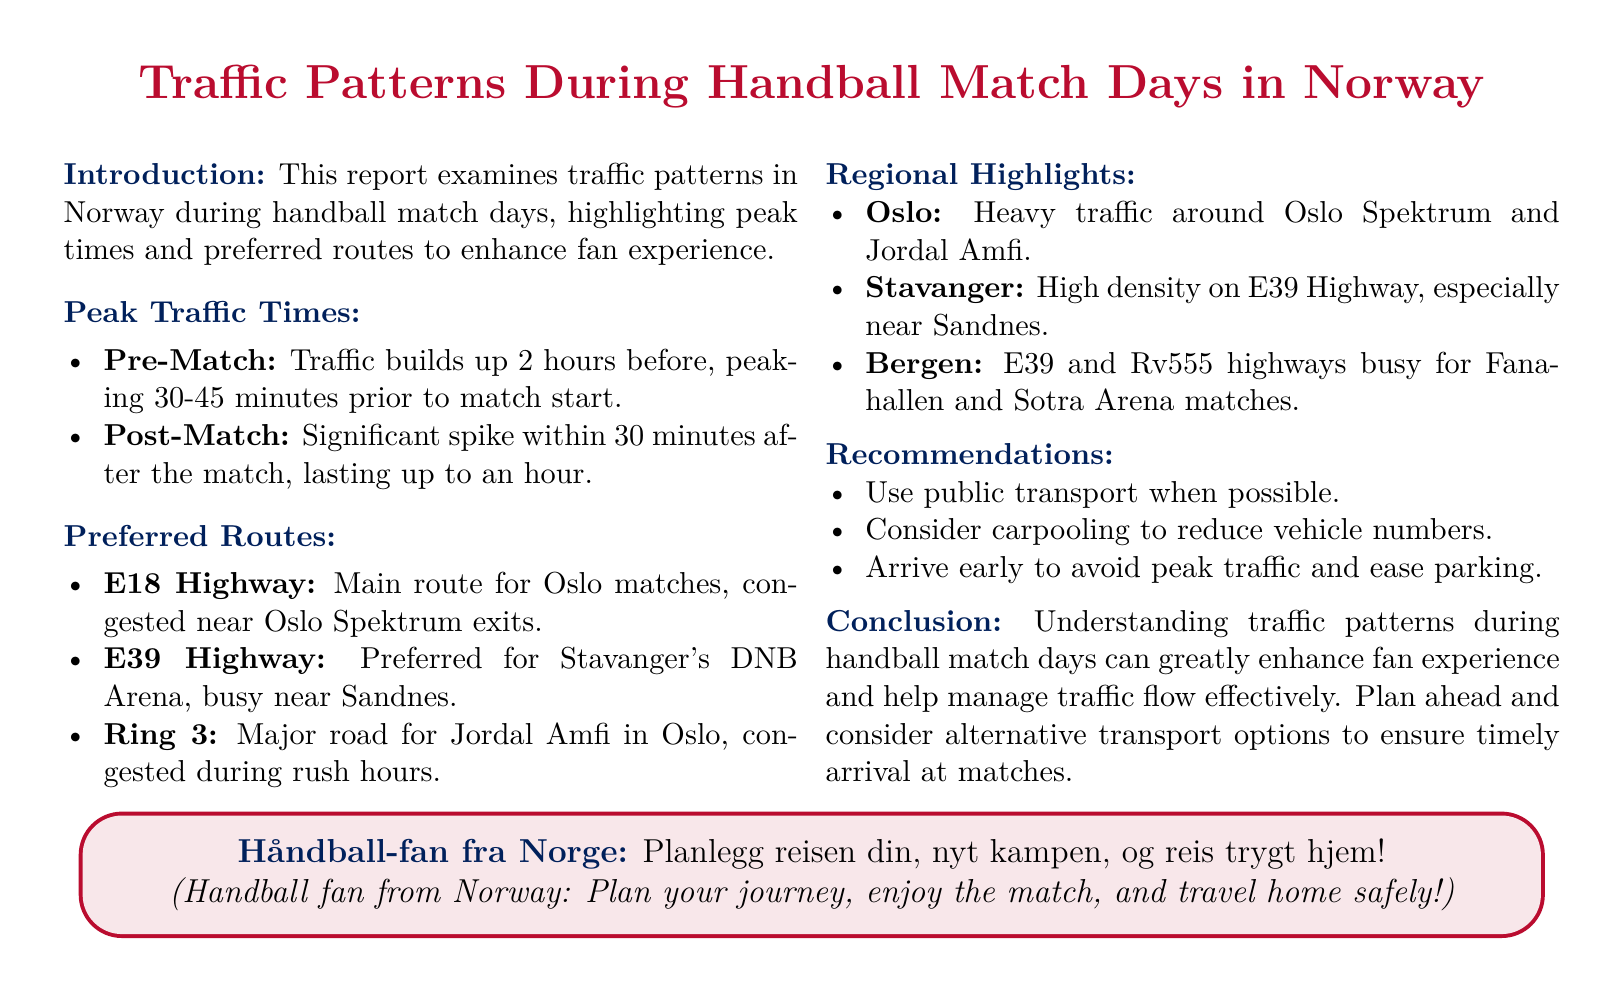What peaks in traffic occur 30-45 minutes before a match? The document states that traffic builds up 2 hours before, peaking 30-45 minutes prior to match start.
Answer: Pre-Match What is the primary route for Oslo matches? The report specifies that the E18 Highway is the main route for Oslo matches.
Answer: E18 Highway What are the peak traffic times after a match? The document mentions a significant spike within 30 minutes after the match, lasting up to an hour.
Answer: 30 minutes Which highway is busiest near Sandnes? The report indicates that the E39 Highway is busy near Sandnes, especially for Stavanger's DNB Arena.
Answer: E39 Highway What is the recommendation to ease traffic on match days? The document recommends considering carpooling to reduce vehicle numbers.
Answer: Carpooling What major road is mentioned for Jordal Amfi? The report states that Ring 3 is a major road for Jordal Amfi in Oslo.
Answer: Ring 3 What is a key takeaway for fans regarding their journey? The conclusion emphasizes planning ahead and considering alternative transport options for timely arrival.
Answer: Plan ahead Which city experiences heavy traffic around Oslo Spektrum? The report specifies that Oslo experiences heavy traffic around Oslo Spektrum and Jordal Amfi.
Answer: Oslo What time do traffic issues typically last after a match? The document indicates that traffic issues typically last up to an hour after a match.
Answer: Up to an hour 